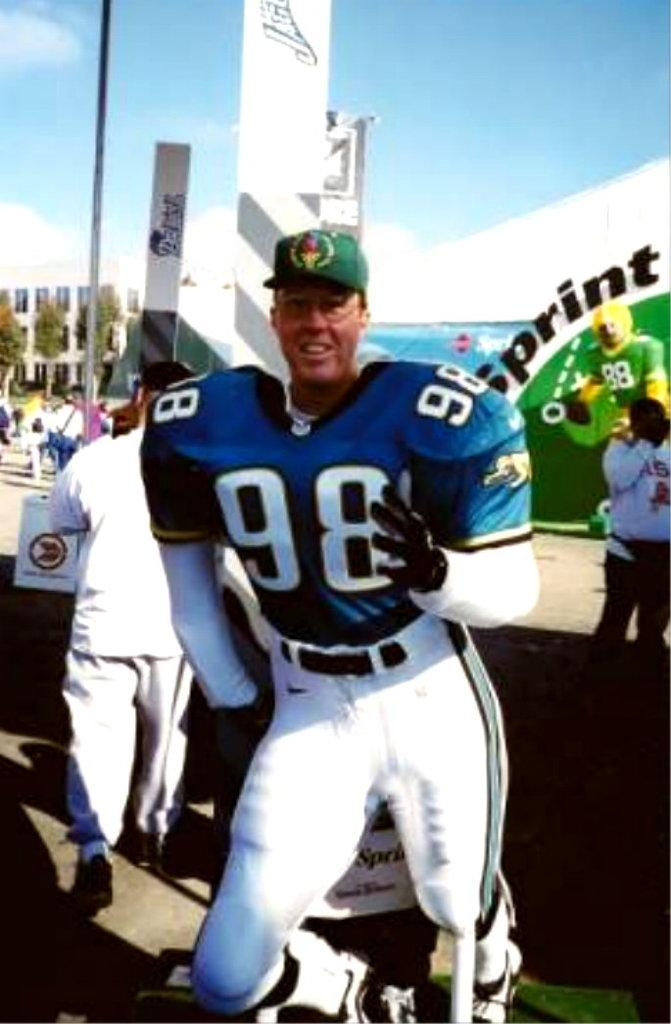Provide a one-sentence caption for the provided image. A man in a football uniform with 98 on the front of his jersey. 